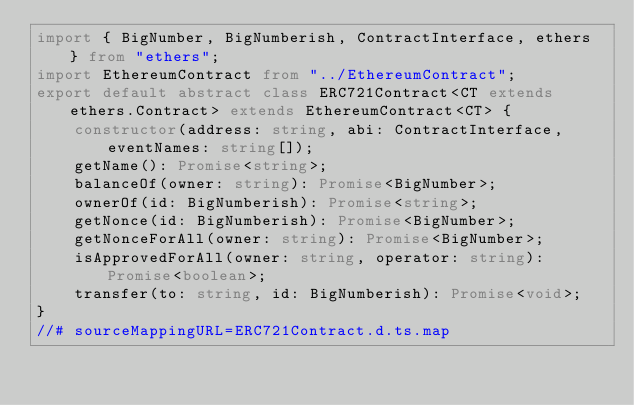Convert code to text. <code><loc_0><loc_0><loc_500><loc_500><_TypeScript_>import { BigNumber, BigNumberish, ContractInterface, ethers } from "ethers";
import EthereumContract from "../EthereumContract";
export default abstract class ERC721Contract<CT extends ethers.Contract> extends EthereumContract<CT> {
    constructor(address: string, abi: ContractInterface, eventNames: string[]);
    getName(): Promise<string>;
    balanceOf(owner: string): Promise<BigNumber>;
    ownerOf(id: BigNumberish): Promise<string>;
    getNonce(id: BigNumberish): Promise<BigNumber>;
    getNonceForAll(owner: string): Promise<BigNumber>;
    isApprovedForAll(owner: string, operator: string): Promise<boolean>;
    transfer(to: string, id: BigNumberish): Promise<void>;
}
//# sourceMappingURL=ERC721Contract.d.ts.map</code> 